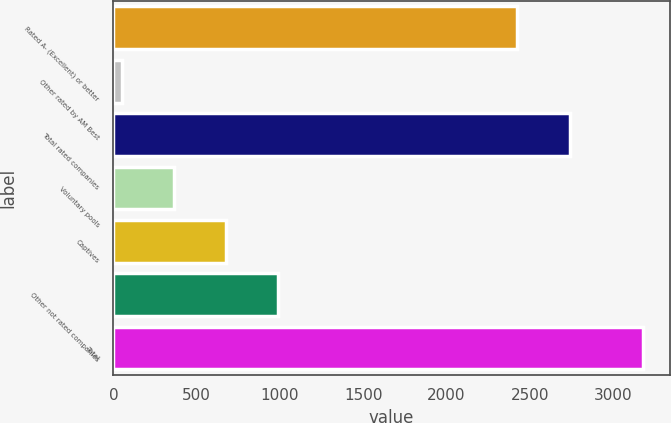<chart> <loc_0><loc_0><loc_500><loc_500><bar_chart><fcel>Rated A- (Excellent) or better<fcel>Other rated by AM Best<fcel>Total rated companies<fcel>Voluntary pools<fcel>Captives<fcel>Other not rated companies<fcel>Total<nl><fcel>2426<fcel>52<fcel>2738.8<fcel>364.8<fcel>677.6<fcel>990.4<fcel>3180<nl></chart> 